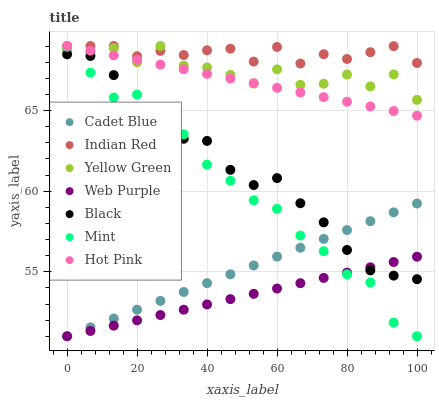Does Web Purple have the minimum area under the curve?
Answer yes or no. Yes. Does Indian Red have the maximum area under the curve?
Answer yes or no. Yes. Does Yellow Green have the minimum area under the curve?
Answer yes or no. No. Does Yellow Green have the maximum area under the curve?
Answer yes or no. No. Is Web Purple the smoothest?
Answer yes or no. Yes. Is Yellow Green the roughest?
Answer yes or no. Yes. Is Hot Pink the smoothest?
Answer yes or no. No. Is Hot Pink the roughest?
Answer yes or no. No. Does Cadet Blue have the lowest value?
Answer yes or no. Yes. Does Yellow Green have the lowest value?
Answer yes or no. No. Does Indian Red have the highest value?
Answer yes or no. Yes. Does Web Purple have the highest value?
Answer yes or no. No. Is Cadet Blue less than Indian Red?
Answer yes or no. Yes. Is Hot Pink greater than Web Purple?
Answer yes or no. Yes. Does Black intersect Mint?
Answer yes or no. Yes. Is Black less than Mint?
Answer yes or no. No. Is Black greater than Mint?
Answer yes or no. No. Does Cadet Blue intersect Indian Red?
Answer yes or no. No. 